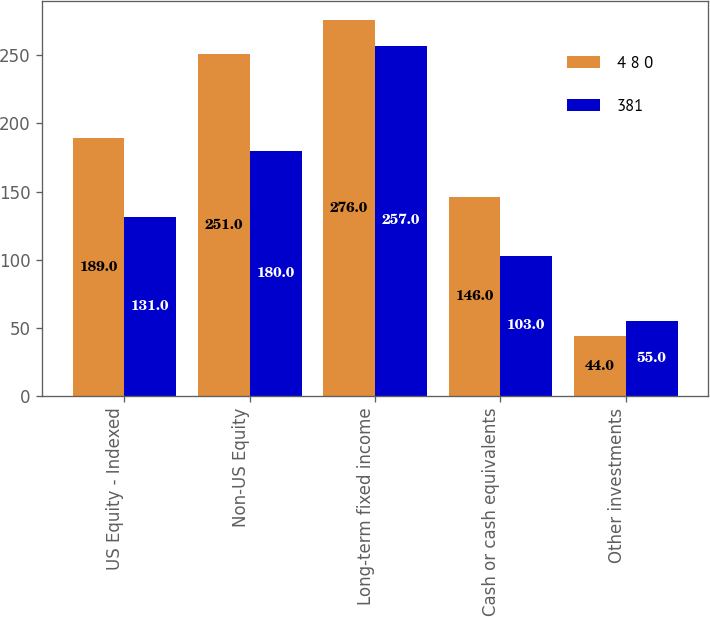Convert chart to OTSL. <chart><loc_0><loc_0><loc_500><loc_500><stacked_bar_chart><ecel><fcel>US Equity - Indexed<fcel>Non-US Equity<fcel>Long-term fixed income<fcel>Cash or cash equivalents<fcel>Other investments<nl><fcel>4 8 0<fcel>189<fcel>251<fcel>276<fcel>146<fcel>44<nl><fcel>381<fcel>131<fcel>180<fcel>257<fcel>103<fcel>55<nl></chart> 